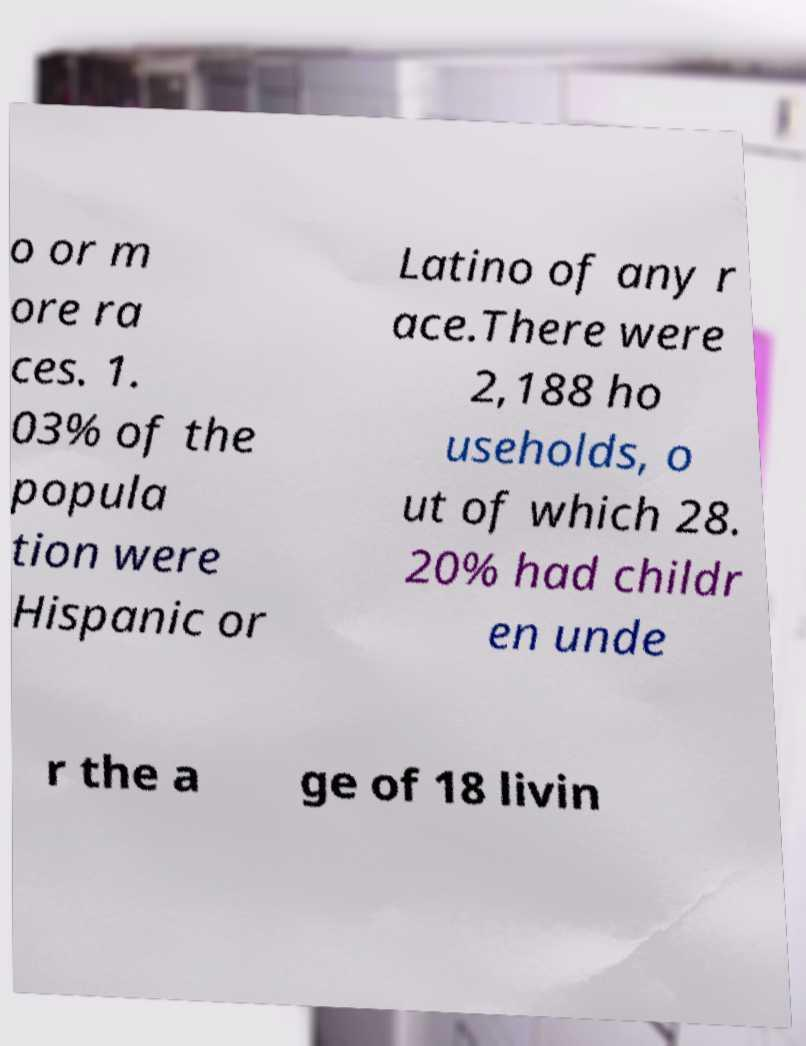Can you read and provide the text displayed in the image?This photo seems to have some interesting text. Can you extract and type it out for me? o or m ore ra ces. 1. 03% of the popula tion were Hispanic or Latino of any r ace.There were 2,188 ho useholds, o ut of which 28. 20% had childr en unde r the a ge of 18 livin 